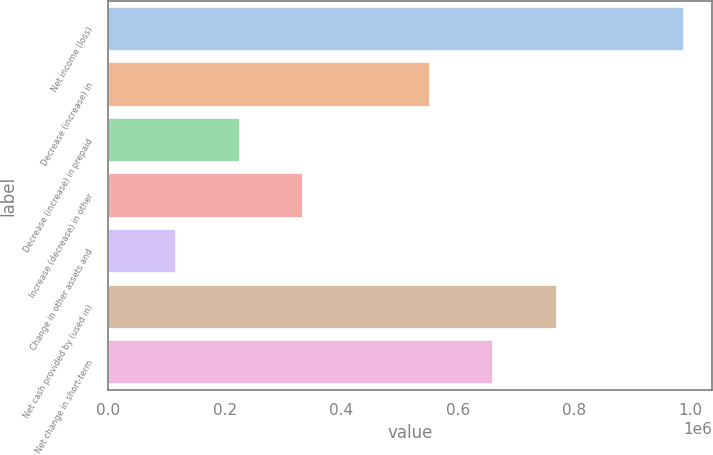<chart> <loc_0><loc_0><loc_500><loc_500><bar_chart><fcel>Net income (loss)<fcel>Decrease (increase) in<fcel>Decrease (increase) in prepaid<fcel>Increase (decrease) in other<fcel>Change in other assets and<fcel>Net cash provided by (used in)<fcel>Net change in short-term<nl><fcel>987749<fcel>552207<fcel>225551<fcel>334436<fcel>116665<fcel>769978<fcel>661092<nl></chart> 